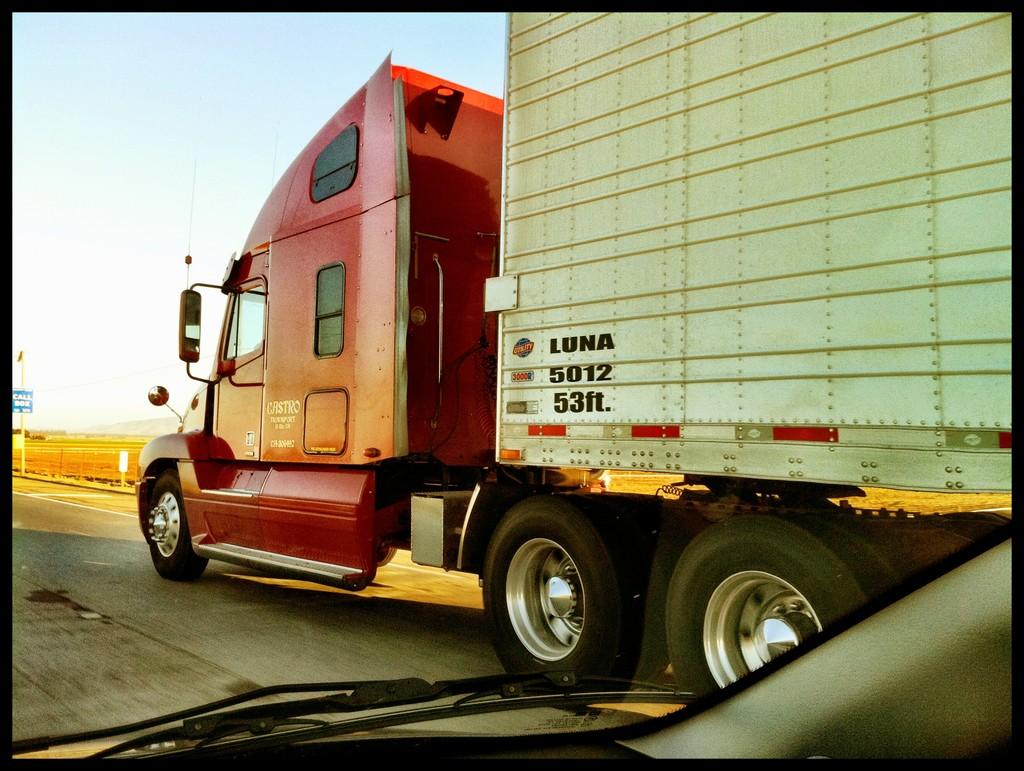What is happening on the road in the image? There are vehicles on the road in the image. What can be seen in the background of the image? There are poles and a fence in the background of the image. What is visible at the top of the image? The sky is visible at the top of the image. Where is the shelf located in the image? There is no shelf present in the image. Who is the expert in the image? There is no expert depicted in the image. 